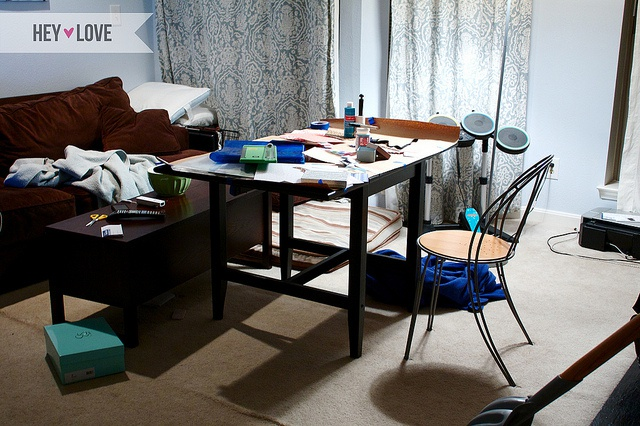Describe the objects in this image and their specific colors. I can see couch in gray, black, lightgray, maroon, and darkgray tones, dining table in gray, black, white, and darkgray tones, chair in gray, black, lightgray, darkgray, and tan tones, bowl in gray, black, white, green, and darkgreen tones, and book in gray, white, black, and maroon tones in this image. 